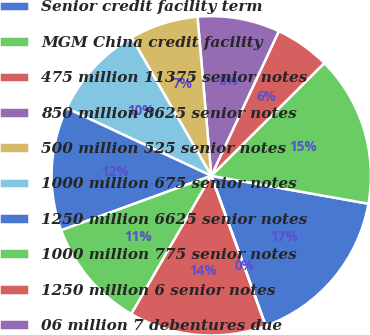Convert chart. <chart><loc_0><loc_0><loc_500><loc_500><pie_chart><fcel>Senior credit facility term<fcel>MGM China credit facility<fcel>475 million 11375 senior notes<fcel>850 million 8625 senior notes<fcel>500 million 525 senior notes<fcel>1000 million 675 senior notes<fcel>1250 million 6625 senior notes<fcel>1000 million 775 senior notes<fcel>1250 million 6 senior notes<fcel>06 million 7 debentures due<nl><fcel>16.66%<fcel>15.28%<fcel>5.56%<fcel>8.33%<fcel>6.95%<fcel>9.72%<fcel>12.5%<fcel>11.11%<fcel>13.89%<fcel>0.0%<nl></chart> 